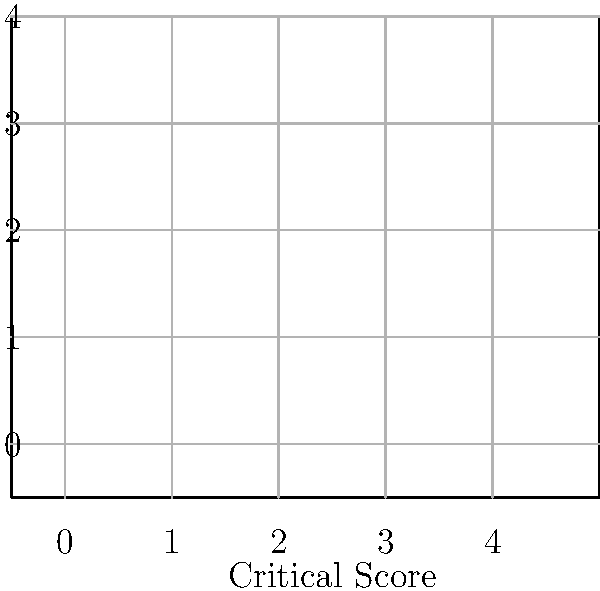As a playwright who has experienced the harsh realities of the theater world, analyze the scatter plot depicting the relationship between critical scores and box office success for various plays. What conclusion can you draw about the correlation between critical acclaim and financial success in the theater industry? To answer this question, we need to examine the scatter plot and look for patterns in the data:

1. Observe the general trend: As we move from left to right (increasing critical scores), there appears to be a slight upward trend in box office numbers.

2. Look for outliers: There don't appear to be any significant outliers that would skew the relationship.

3. Assess the strength of the relationship:
   - The points are not tightly clustered around a single line.
   - There is some scatter, indicating variability in the relationship.

4. Consider the slope: The overall trend suggests a positive slope, meaning that as critical scores increase, box office numbers tend to increase as well.

5. Evaluate the consistency: While there is a general positive trend, it's not perfect. Some plays with lower critical scores still achieved decent box office numbers, and some highly-rated plays didn't perform as well financially.

6. Draw a conclusion: Based on these observations, we can conclude that there is a moderate positive correlation between critical acclaim and box office success. However, the relationship is not strong enough to guarantee that high critical scores will always lead to high box office numbers, or vice versa.

This conclusion reflects the complex nature of the theater industry, where factors beyond critical reception (such as marketing, word-of-mouth, and subject matter) can significantly influence a play's financial success.
Answer: Moderate positive correlation with significant variability 